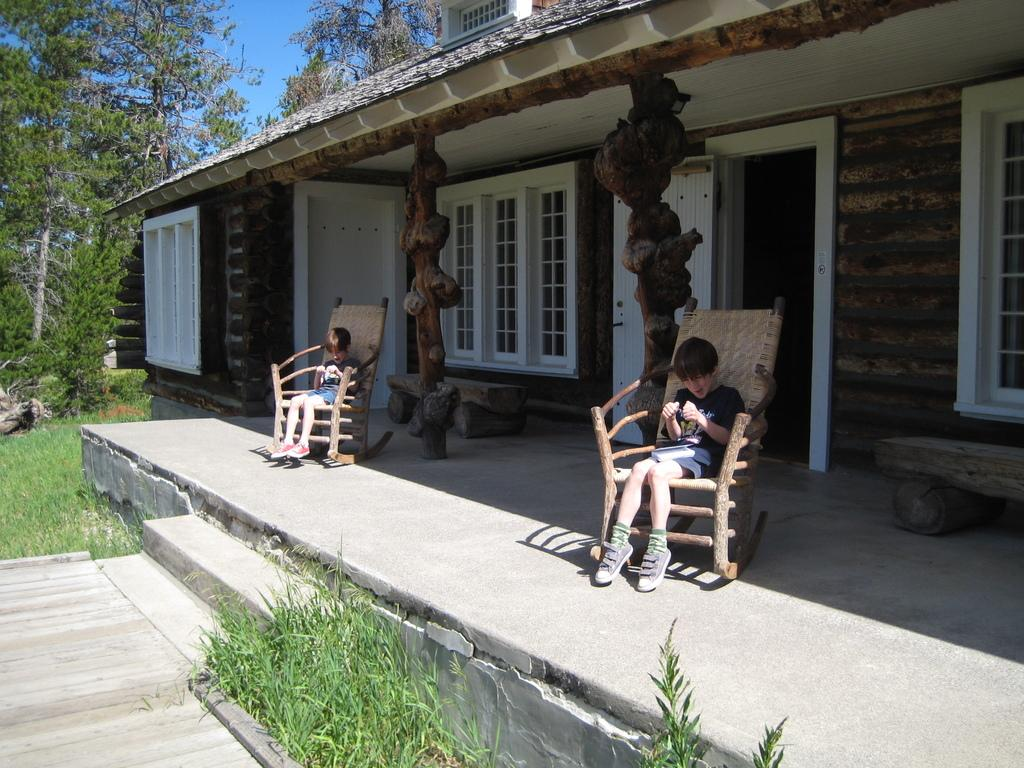What type of vegetation can be seen in the image? There are trees in the image. What type of structure is present in the image? There is a house in the image. What part of the house is visible in the image? There is a door and windows in the image. What are the people in the image doing? There are two people sitting on chairs in the image. What is the ground made of in the image? There is grass in the image. Can you hear the rhythm of the jellyfish in the image? There are no jellyfish present in the image, so there is no rhythm to be heard. 